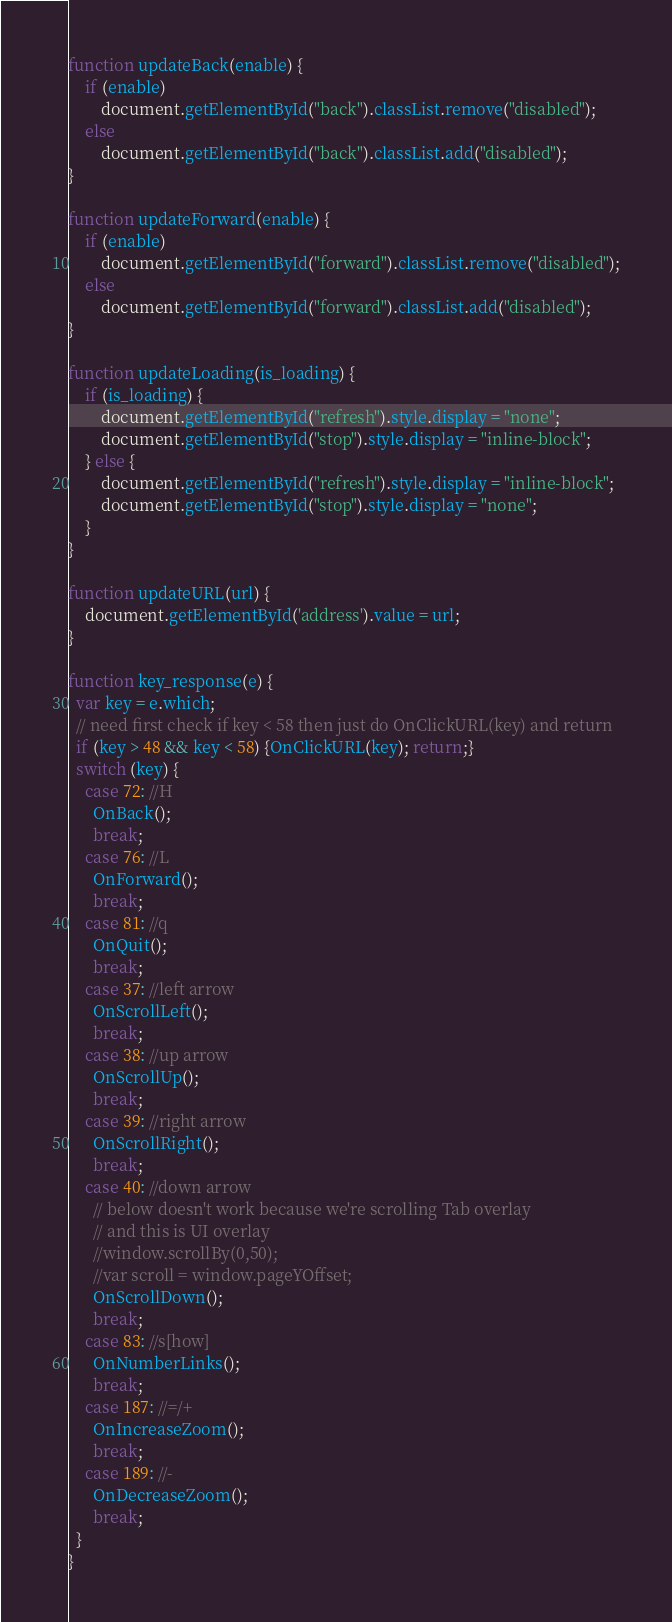<code> <loc_0><loc_0><loc_500><loc_500><_JavaScript_>function updateBack(enable) {
    if (enable)
		document.getElementById("back").classList.remove("disabled");
	else
		document.getElementById("back").classList.add("disabled");
}

function updateForward(enable) {
    if (enable)
		document.getElementById("forward").classList.remove("disabled");
	else
		document.getElementById("forward").classList.add("disabled");
}

function updateLoading(is_loading) {
    if (is_loading) {
		document.getElementById("refresh").style.display = "none";
		document.getElementById("stop").style.display = "inline-block";
	} else {
		document.getElementById("refresh").style.display = "inline-block";
		document.getElementById("stop").style.display = "none";
	}
}

function updateURL(url) {
	document.getElementById('address').value = url;
}

function key_response(e) {
  var key = e.which;
  // need first check if key < 58 then just do OnClickURL(key) and return
  if (key > 48 && key < 58) {OnClickURL(key); return;}
  switch (key) {
    case 72: //H
      OnBack();
      break;
    case 76: //L
      OnForward();
      break;
    case 81: //q
      OnQuit();
      break;
    case 37: //left arrow
      OnScrollLeft();
      break;
    case 38: //up arrow
      OnScrollUp();
      break;
    case 39: //right arrow
      OnScrollRight();
      break;
    case 40: //down arrow
      // below doesn't work because we're scrolling Tab overlay
      // and this is UI overlay
      //window.scrollBy(0,50);
      //var scroll = window.pageYOffset;
      OnScrollDown();
      break;
    case 83: //s[how]
      OnNumberLinks();
      break;
    case 187: //=/+  
      OnIncreaseZoom();
      break;
    case 189: //-  
      OnDecreaseZoom();
      break;
  }    
}
</code> 